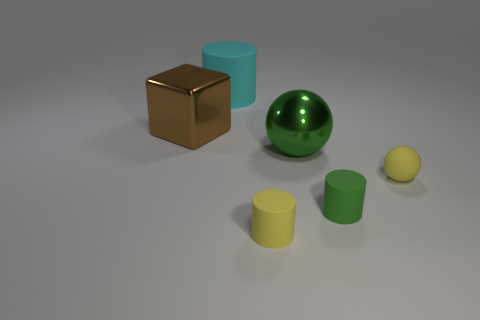Subtract all green blocks. Subtract all yellow balls. How many blocks are left? 1 Add 2 brown matte cubes. How many objects exist? 8 Subtract all blocks. How many objects are left? 5 Subtract 1 green cylinders. How many objects are left? 5 Subtract all big yellow rubber blocks. Subtract all small green rubber cylinders. How many objects are left? 5 Add 2 large cylinders. How many large cylinders are left? 3 Add 5 large green metallic spheres. How many large green metallic spheres exist? 6 